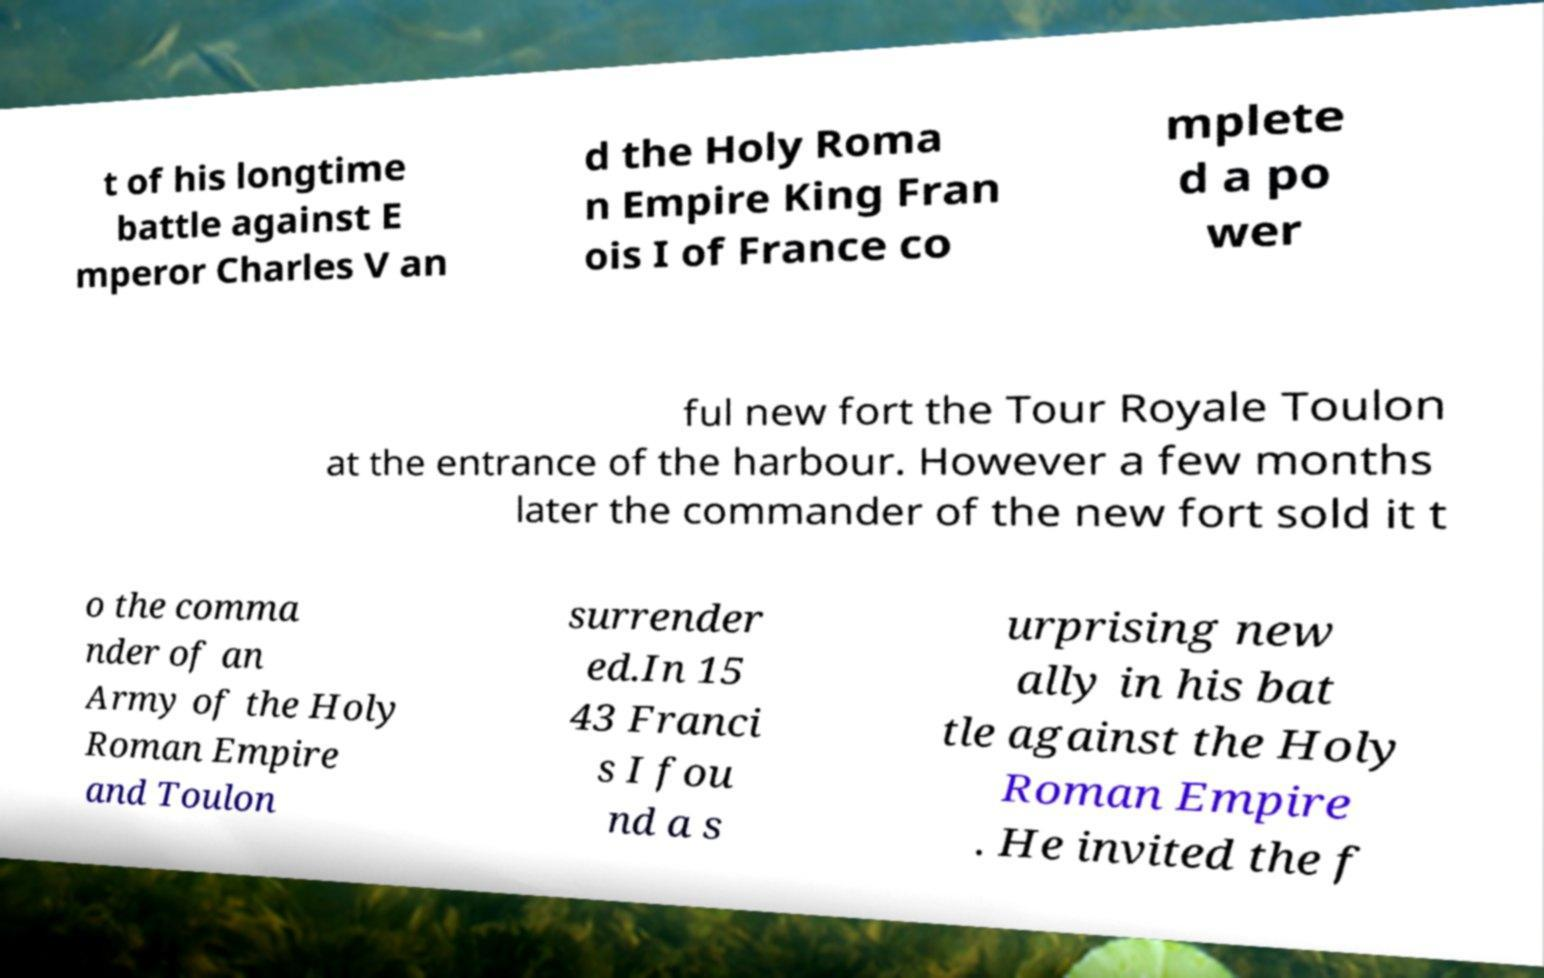There's text embedded in this image that I need extracted. Can you transcribe it verbatim? t of his longtime battle against E mperor Charles V an d the Holy Roma n Empire King Fran ois I of France co mplete d a po wer ful new fort the Tour Royale Toulon at the entrance of the harbour. However a few months later the commander of the new fort sold it t o the comma nder of an Army of the Holy Roman Empire and Toulon surrender ed.In 15 43 Franci s I fou nd a s urprising new ally in his bat tle against the Holy Roman Empire . He invited the f 